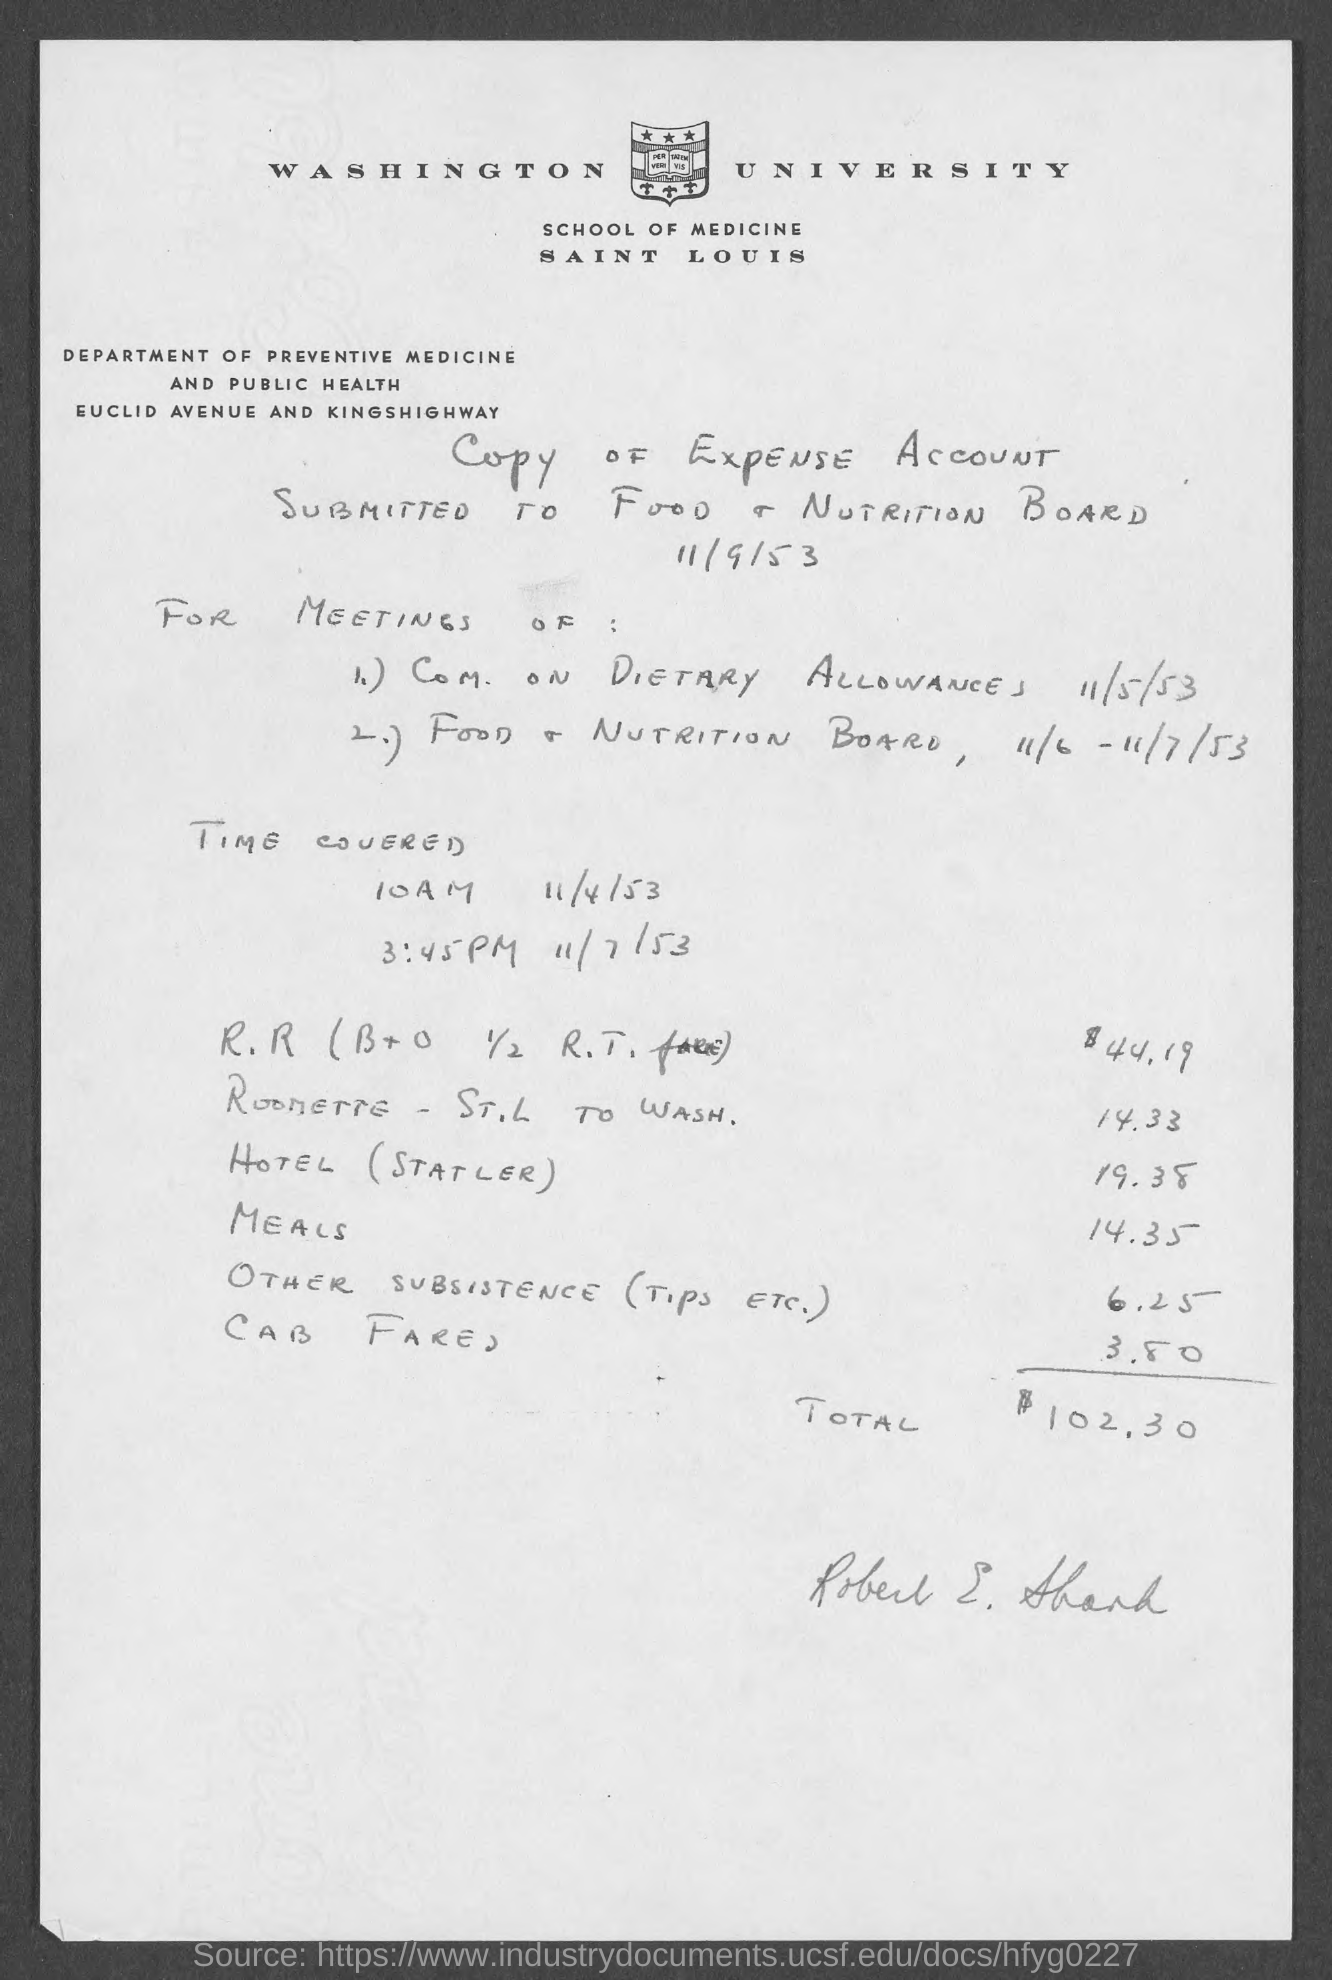What is the city address of washington university ?
Provide a succinct answer. Saint Louis. What is the total amount expenses ?
Your answer should be compact. 102.30. To whom is this expense account submitted ?
Make the answer very short. To food & nutrition board. 